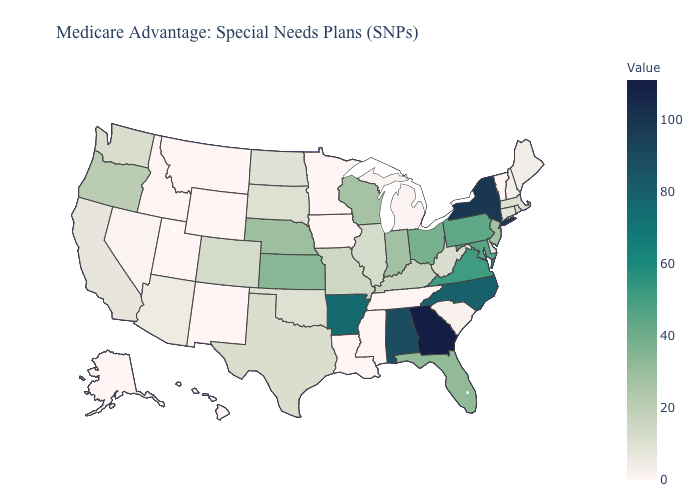Which states have the highest value in the USA?
Give a very brief answer. Georgia. Among the states that border Kentucky , does Virginia have the highest value?
Concise answer only. Yes. Among the states that border Nevada , which have the highest value?
Give a very brief answer. Oregon. Is the legend a continuous bar?
Quick response, please. Yes. Does New Mexico have the lowest value in the USA?
Give a very brief answer. Yes. 